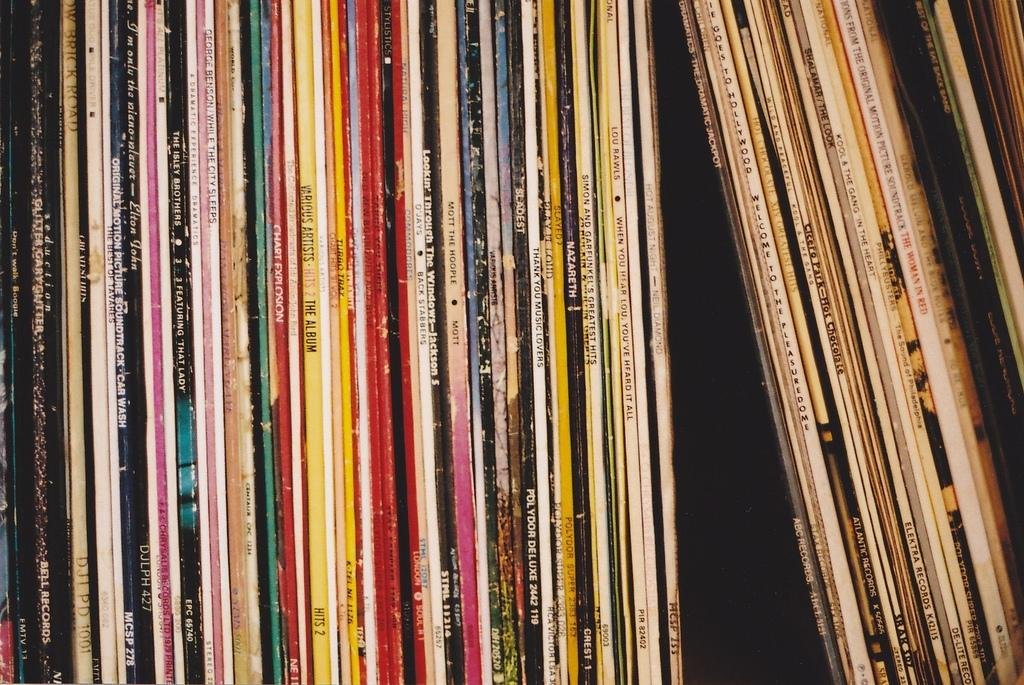<image>
Offer a succinct explanation of the picture presented. A variety of albums on a shelf including one by Lou Rawls called When You Hear Lou, You've Heard It All 